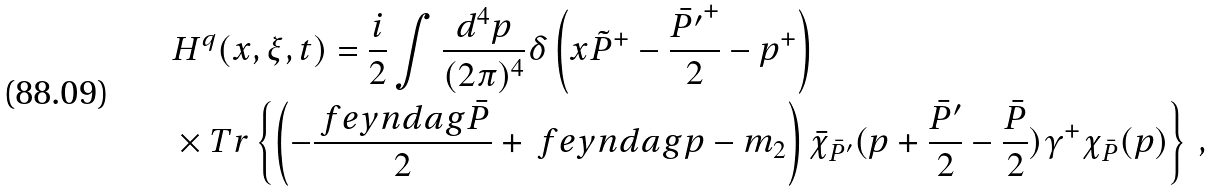Convert formula to latex. <formula><loc_0><loc_0><loc_500><loc_500>& H ^ { q } ( x , \xi , t ) = \frac { i } { 2 } \int \frac { d ^ { 4 } p } { ( 2 \pi ) ^ { 4 } } \delta \left ( x \tilde { P } ^ { + } - \frac { \bar { P ^ { \prime } } ^ { + } } { 2 } - p ^ { + } \right ) \\ & \times T r \left \{ \left ( - \frac { \ f e y n d a g { \bar { P } } } { 2 } + \ f e y n d a g { p } - m _ { 2 } \right ) \bar { \chi } _ { \bar { P } ^ { \prime } } ( p + \frac { \bar { P } ^ { \prime } } { 2 } - \frac { \bar { P } } { 2 } ) \gamma ^ { + } \chi _ { \bar { P } } ( p ) \right \} \, ,</formula> 